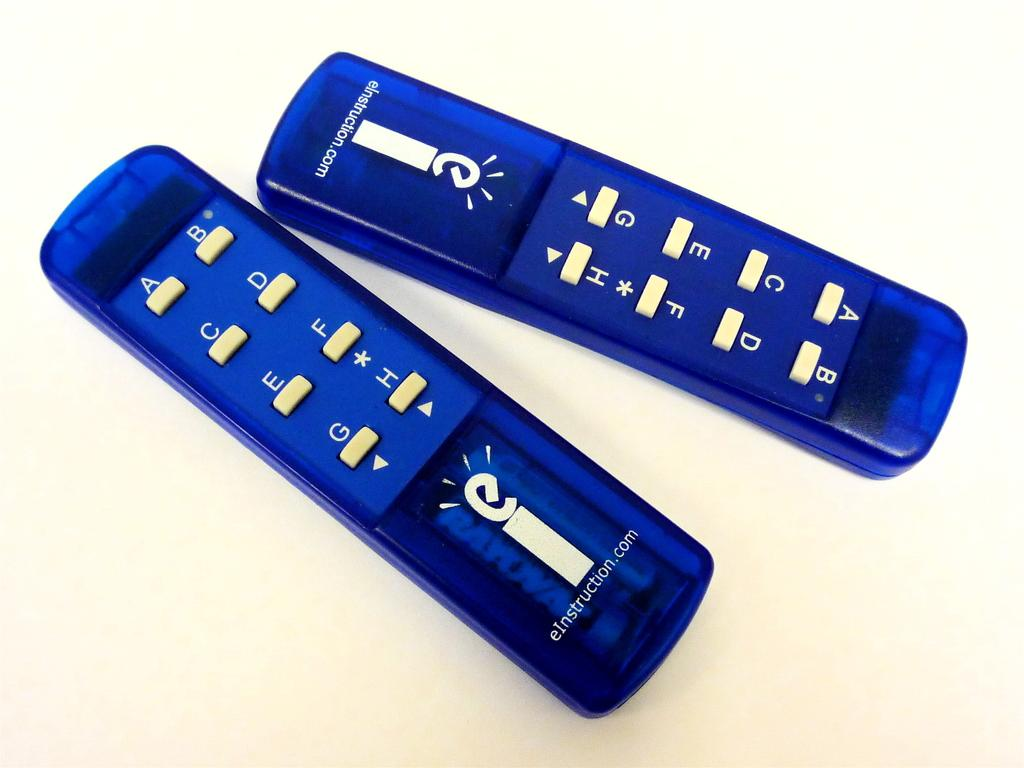<image>
Share a concise interpretation of the image provided. 2 blue remote controls with buttons labeled A-H from eInstruction.com. 